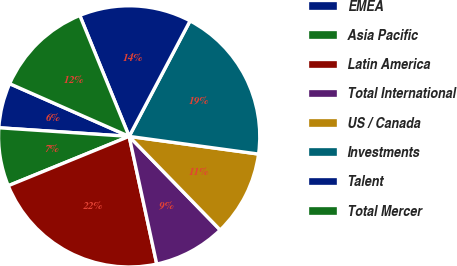Convert chart to OTSL. <chart><loc_0><loc_0><loc_500><loc_500><pie_chart><fcel>EMEA<fcel>Asia Pacific<fcel>Latin America<fcel>Total International<fcel>US / Canada<fcel>Investments<fcel>Talent<fcel>Total Mercer<nl><fcel>5.56%<fcel>7.22%<fcel>22.22%<fcel>8.89%<fcel>10.56%<fcel>19.44%<fcel>13.89%<fcel>12.22%<nl></chart> 